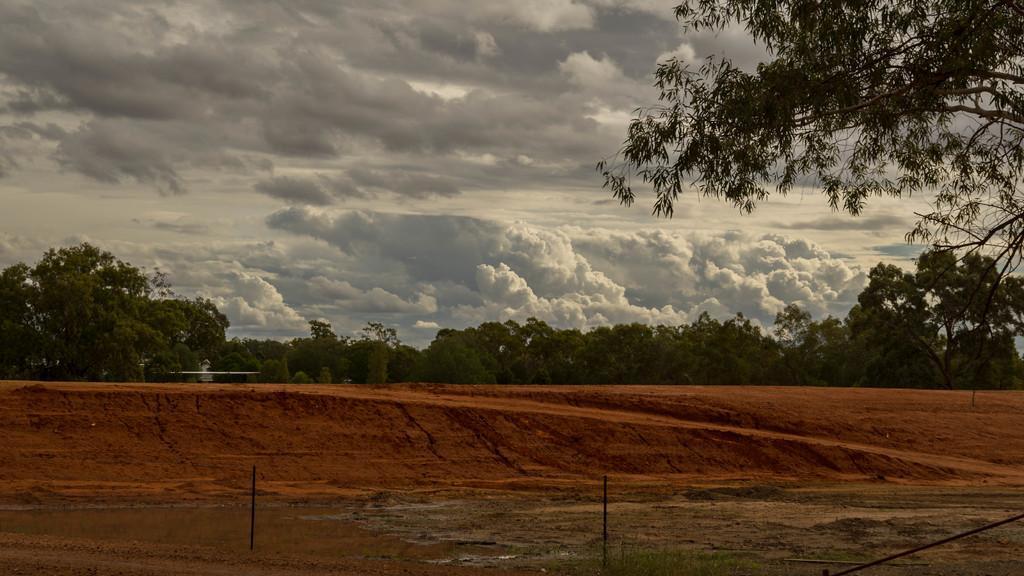Can you describe this image briefly? In this picture we can see many trees. At the top we can see sky and clouds. On the bottom we can see pole and grass. 